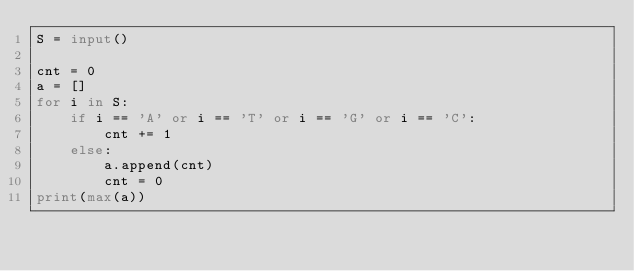<code> <loc_0><loc_0><loc_500><loc_500><_Python_>S = input()

cnt = 0
a = []
for i in S:
    if i == 'A' or i == 'T' or i == 'G' or i == 'C':
        cnt += 1
    else:
        a.append(cnt)
        cnt = 0
print(max(a))</code> 